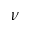<formula> <loc_0><loc_0><loc_500><loc_500>\nu</formula> 